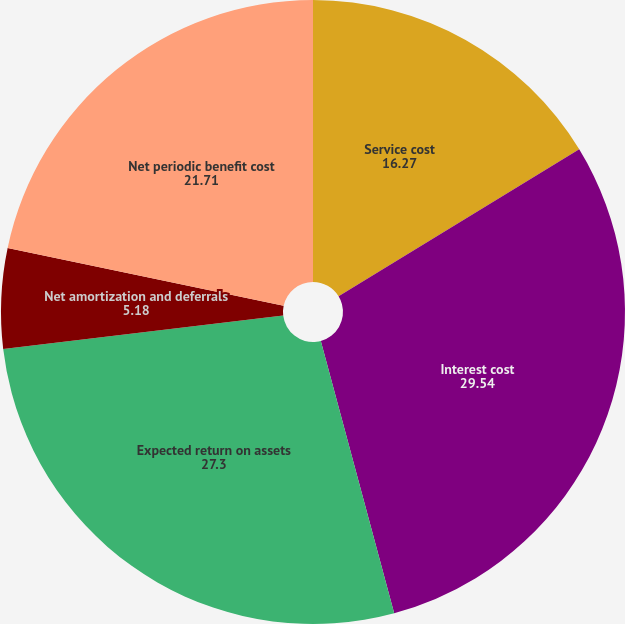Convert chart to OTSL. <chart><loc_0><loc_0><loc_500><loc_500><pie_chart><fcel>Service cost<fcel>Interest cost<fcel>Expected return on assets<fcel>Net amortization and deferrals<fcel>Net periodic benefit cost<nl><fcel>16.27%<fcel>29.54%<fcel>27.3%<fcel>5.18%<fcel>21.71%<nl></chart> 